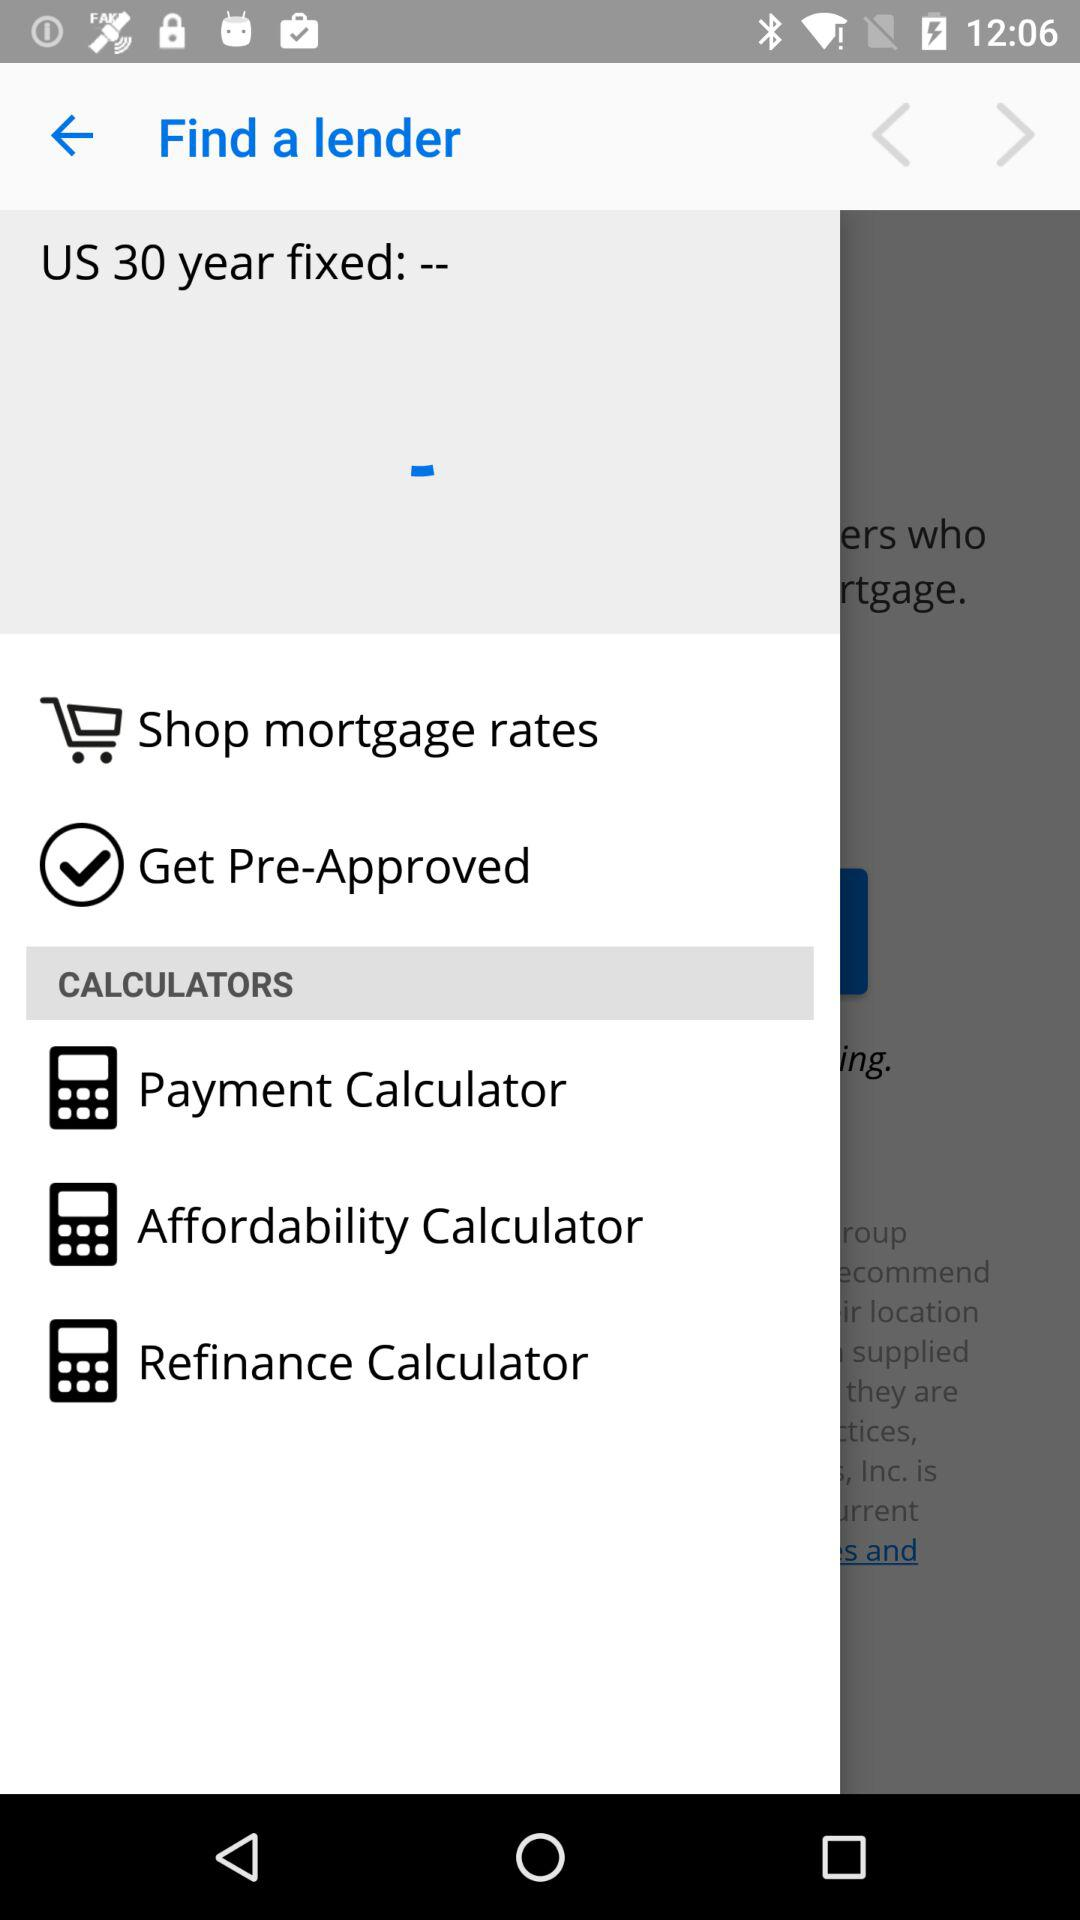What is the fixed number of years? The fixed number of years is 30. 